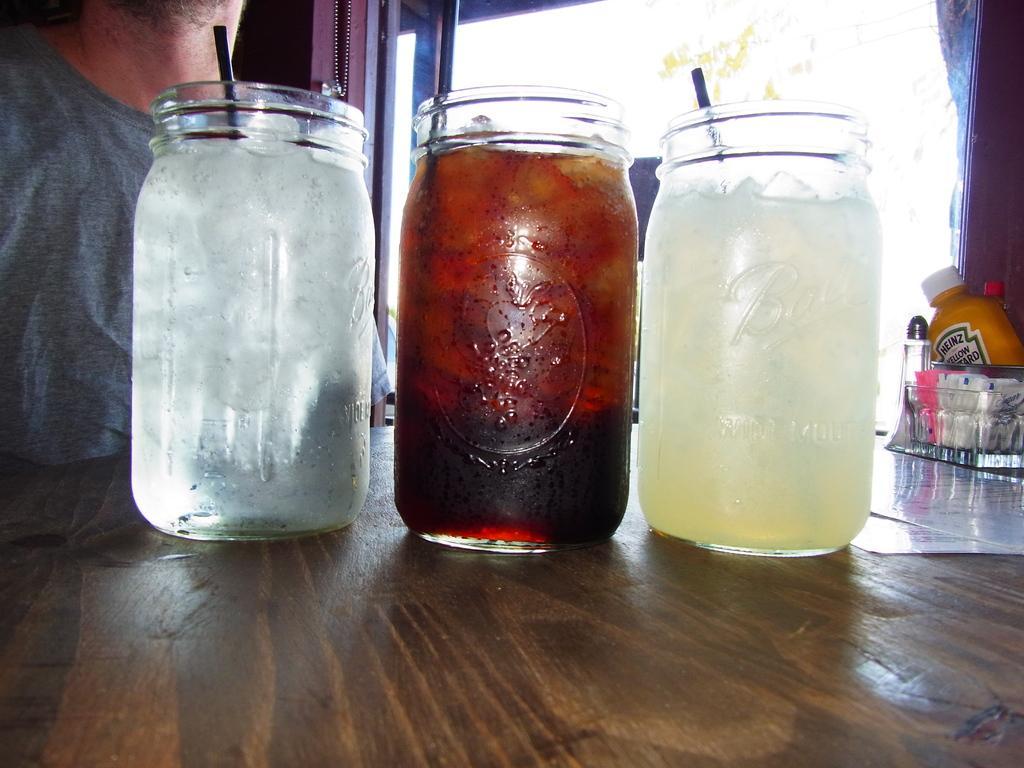Please provide a concise description of this image. In the image in the center we can see three jars they were filling with juice. They are on the table and back of table we can see one person is standing on the left corner. 